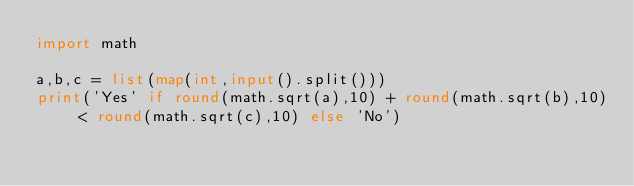<code> <loc_0><loc_0><loc_500><loc_500><_Python_>import math

a,b,c = list(map(int,input().split()))
print('Yes' if round(math.sqrt(a),10) + round(math.sqrt(b),10) < round(math.sqrt(c),10) else 'No') </code> 